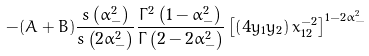Convert formula to latex. <formula><loc_0><loc_0><loc_500><loc_500>- ( A + B ) \frac { s \left ( \alpha _ { - } ^ { 2 } \right ) } { s \left ( 2 \alpha _ { - } ^ { 2 } \right ) } \frac { \Gamma ^ { 2 } \left ( 1 - \alpha _ { - } ^ { 2 } \right ) } { \Gamma \left ( 2 - 2 \alpha _ { - } ^ { 2 } \right ) } \left [ \left ( 4 y _ { 1 } y _ { 2 } \right ) x _ { 1 2 } ^ { - 2 } \right ] ^ { 1 - 2 \alpha _ { - } ^ { 2 } }</formula> 